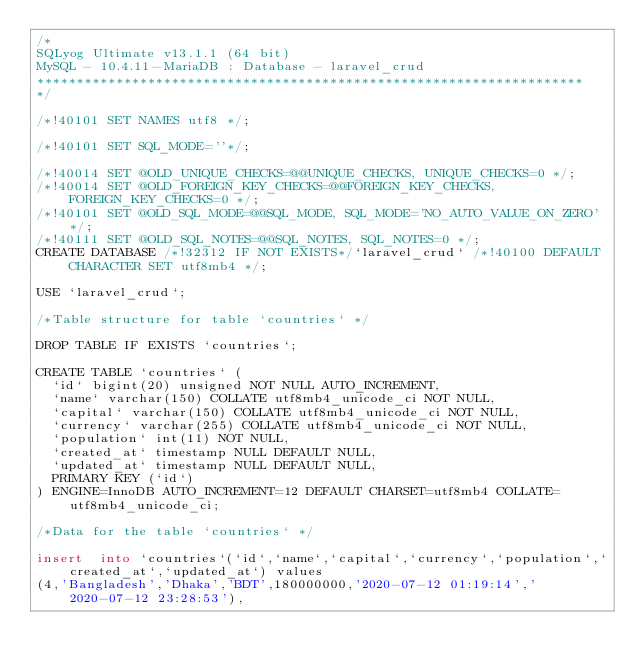Convert code to text. <code><loc_0><loc_0><loc_500><loc_500><_SQL_>/*
SQLyog Ultimate v13.1.1 (64 bit)
MySQL - 10.4.11-MariaDB : Database - laravel_crud
*********************************************************************
*/

/*!40101 SET NAMES utf8 */;

/*!40101 SET SQL_MODE=''*/;

/*!40014 SET @OLD_UNIQUE_CHECKS=@@UNIQUE_CHECKS, UNIQUE_CHECKS=0 */;
/*!40014 SET @OLD_FOREIGN_KEY_CHECKS=@@FOREIGN_KEY_CHECKS, FOREIGN_KEY_CHECKS=0 */;
/*!40101 SET @OLD_SQL_MODE=@@SQL_MODE, SQL_MODE='NO_AUTO_VALUE_ON_ZERO' */;
/*!40111 SET @OLD_SQL_NOTES=@@SQL_NOTES, SQL_NOTES=0 */;
CREATE DATABASE /*!32312 IF NOT EXISTS*/`laravel_crud` /*!40100 DEFAULT CHARACTER SET utf8mb4 */;

USE `laravel_crud`;

/*Table structure for table `countries` */

DROP TABLE IF EXISTS `countries`;

CREATE TABLE `countries` (
  `id` bigint(20) unsigned NOT NULL AUTO_INCREMENT,
  `name` varchar(150) COLLATE utf8mb4_unicode_ci NOT NULL,
  `capital` varchar(150) COLLATE utf8mb4_unicode_ci NOT NULL,
  `currency` varchar(255) COLLATE utf8mb4_unicode_ci NOT NULL,
  `population` int(11) NOT NULL,
  `created_at` timestamp NULL DEFAULT NULL,
  `updated_at` timestamp NULL DEFAULT NULL,
  PRIMARY KEY (`id`)
) ENGINE=InnoDB AUTO_INCREMENT=12 DEFAULT CHARSET=utf8mb4 COLLATE=utf8mb4_unicode_ci;

/*Data for the table `countries` */

insert  into `countries`(`id`,`name`,`capital`,`currency`,`population`,`created_at`,`updated_at`) values 
(4,'Bangladesh','Dhaka','BDT',180000000,'2020-07-12 01:19:14','2020-07-12 23:28:53'),</code> 